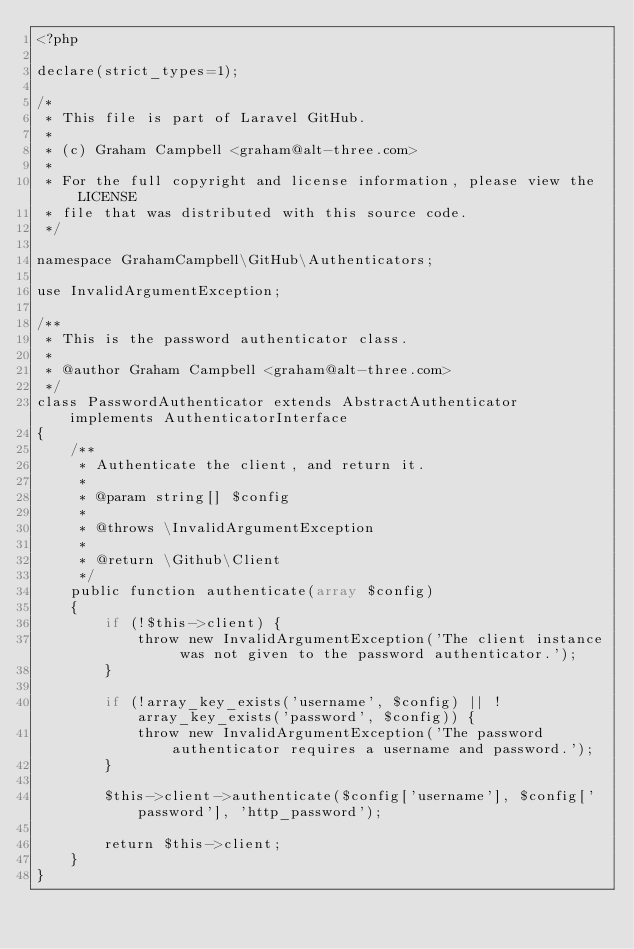Convert code to text. <code><loc_0><loc_0><loc_500><loc_500><_PHP_><?php

declare(strict_types=1);

/*
 * This file is part of Laravel GitHub.
 *
 * (c) Graham Campbell <graham@alt-three.com>
 *
 * For the full copyright and license information, please view the LICENSE
 * file that was distributed with this source code.
 */

namespace GrahamCampbell\GitHub\Authenticators;

use InvalidArgumentException;

/**
 * This is the password authenticator class.
 *
 * @author Graham Campbell <graham@alt-three.com>
 */
class PasswordAuthenticator extends AbstractAuthenticator implements AuthenticatorInterface
{
    /**
     * Authenticate the client, and return it.
     *
     * @param string[] $config
     *
     * @throws \InvalidArgumentException
     *
     * @return \Github\Client
     */
    public function authenticate(array $config)
    {
        if (!$this->client) {
            throw new InvalidArgumentException('The client instance was not given to the password authenticator.');
        }

        if (!array_key_exists('username', $config) || !array_key_exists('password', $config)) {
            throw new InvalidArgumentException('The password authenticator requires a username and password.');
        }

        $this->client->authenticate($config['username'], $config['password'], 'http_password');

        return $this->client;
    }
}
</code> 